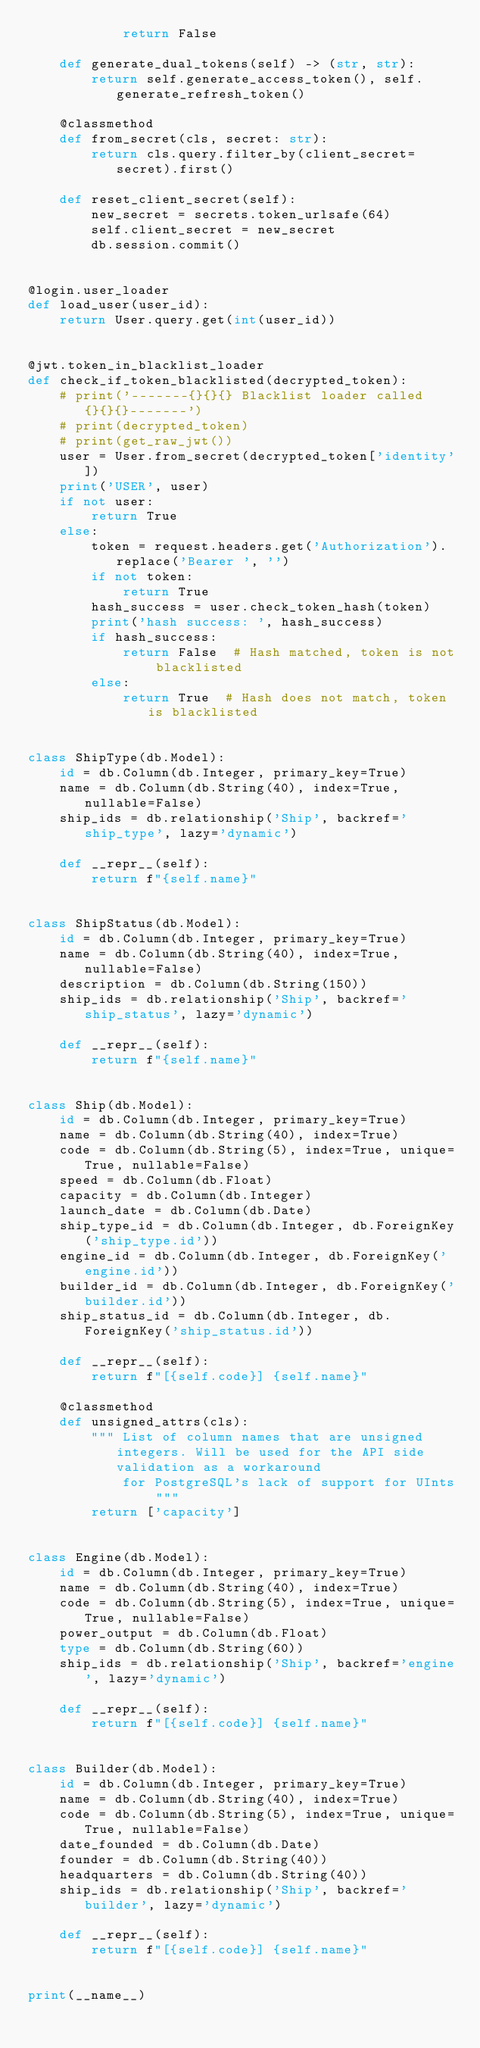<code> <loc_0><loc_0><loc_500><loc_500><_Python_>            return False

    def generate_dual_tokens(self) -> (str, str):
        return self.generate_access_token(), self.generate_refresh_token()

    @classmethod
    def from_secret(cls, secret: str):
        return cls.query.filter_by(client_secret=secret).first()

    def reset_client_secret(self):
        new_secret = secrets.token_urlsafe(64)
        self.client_secret = new_secret
        db.session.commit()


@login.user_loader
def load_user(user_id):
    return User.query.get(int(user_id))


@jwt.token_in_blacklist_loader
def check_if_token_blacklisted(decrypted_token):
    # print('-------{}{}{} Blacklist loader called {}{}{}-------')
    # print(decrypted_token)
    # print(get_raw_jwt())
    user = User.from_secret(decrypted_token['identity'])
    print('USER', user)
    if not user:
        return True
    else:
        token = request.headers.get('Authorization').replace('Bearer ', '')
        if not token:
            return True
        hash_success = user.check_token_hash(token)
        print('hash success: ', hash_success)
        if hash_success:
            return False  # Hash matched, token is not blacklisted
        else:
            return True  # Hash does not match, token is blacklisted


class ShipType(db.Model):
    id = db.Column(db.Integer, primary_key=True)
    name = db.Column(db.String(40), index=True, nullable=False)
    ship_ids = db.relationship('Ship', backref='ship_type', lazy='dynamic')

    def __repr__(self):
        return f"{self.name}"


class ShipStatus(db.Model):
    id = db.Column(db.Integer, primary_key=True)
    name = db.Column(db.String(40), index=True, nullable=False)
    description = db.Column(db.String(150))
    ship_ids = db.relationship('Ship', backref='ship_status', lazy='dynamic')

    def __repr__(self):
        return f"{self.name}"


class Ship(db.Model):
    id = db.Column(db.Integer, primary_key=True)
    name = db.Column(db.String(40), index=True)
    code = db.Column(db.String(5), index=True, unique=True, nullable=False)
    speed = db.Column(db.Float)
    capacity = db.Column(db.Integer)
    launch_date = db.Column(db.Date)
    ship_type_id = db.Column(db.Integer, db.ForeignKey('ship_type.id'))
    engine_id = db.Column(db.Integer, db.ForeignKey('engine.id'))
    builder_id = db.Column(db.Integer, db.ForeignKey('builder.id'))
    ship_status_id = db.Column(db.Integer, db.ForeignKey('ship_status.id'))

    def __repr__(self):
        return f"[{self.code}] {self.name}"

    @classmethod
    def unsigned_attrs(cls):
        """ List of column names that are unsigned integers. Will be used for the API side validation as a workaround
            for PostgreSQL's lack of support for UInts """
        return ['capacity']


class Engine(db.Model):
    id = db.Column(db.Integer, primary_key=True)
    name = db.Column(db.String(40), index=True)
    code = db.Column(db.String(5), index=True, unique=True, nullable=False)
    power_output = db.Column(db.Float)
    type = db.Column(db.String(60))
    ship_ids = db.relationship('Ship', backref='engine', lazy='dynamic')

    def __repr__(self):
        return f"[{self.code}] {self.name}"


class Builder(db.Model):
    id = db.Column(db.Integer, primary_key=True)
    name = db.Column(db.String(40), index=True)
    code = db.Column(db.String(5), index=True, unique=True, nullable=False)
    date_founded = db.Column(db.Date)
    founder = db.Column(db.String(40))
    headquarters = db.Column(db.String(40))
    ship_ids = db.relationship('Ship', backref='builder', lazy='dynamic')

    def __repr__(self):
        return f"[{self.code}] {self.name}"


print(__name__)
</code> 